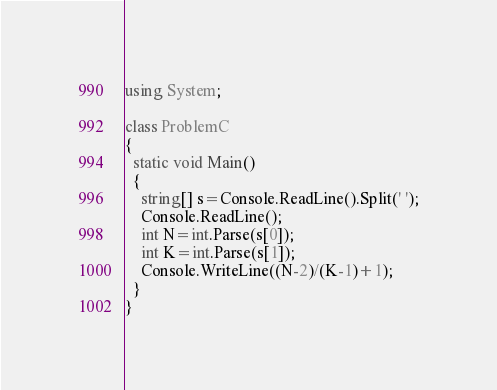Convert code to text. <code><loc_0><loc_0><loc_500><loc_500><_C#_>using System;

class ProblemC
{
  static void Main()
  {
    string[] s=Console.ReadLine().Split(' ');
    Console.ReadLine();
    int N=int.Parse(s[0]);
    int K=int.Parse(s[1]);
    Console.WriteLine((N-2)/(K-1)+1);
  }
}</code> 